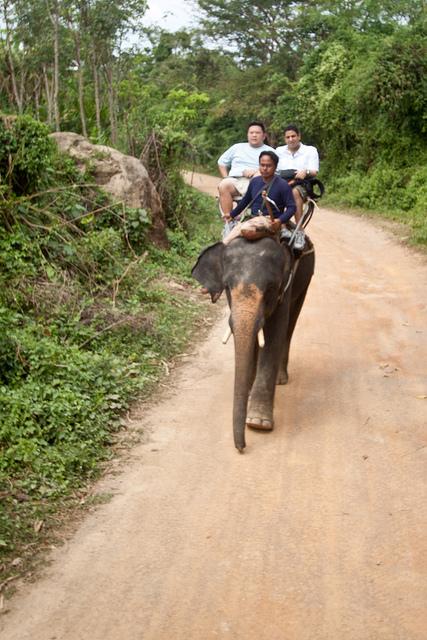What race is the person in the front?
Short answer required. Indian. What are the men riding on?
Write a very short answer. Elephant. What color is the animal?
Give a very brief answer. Gray. 